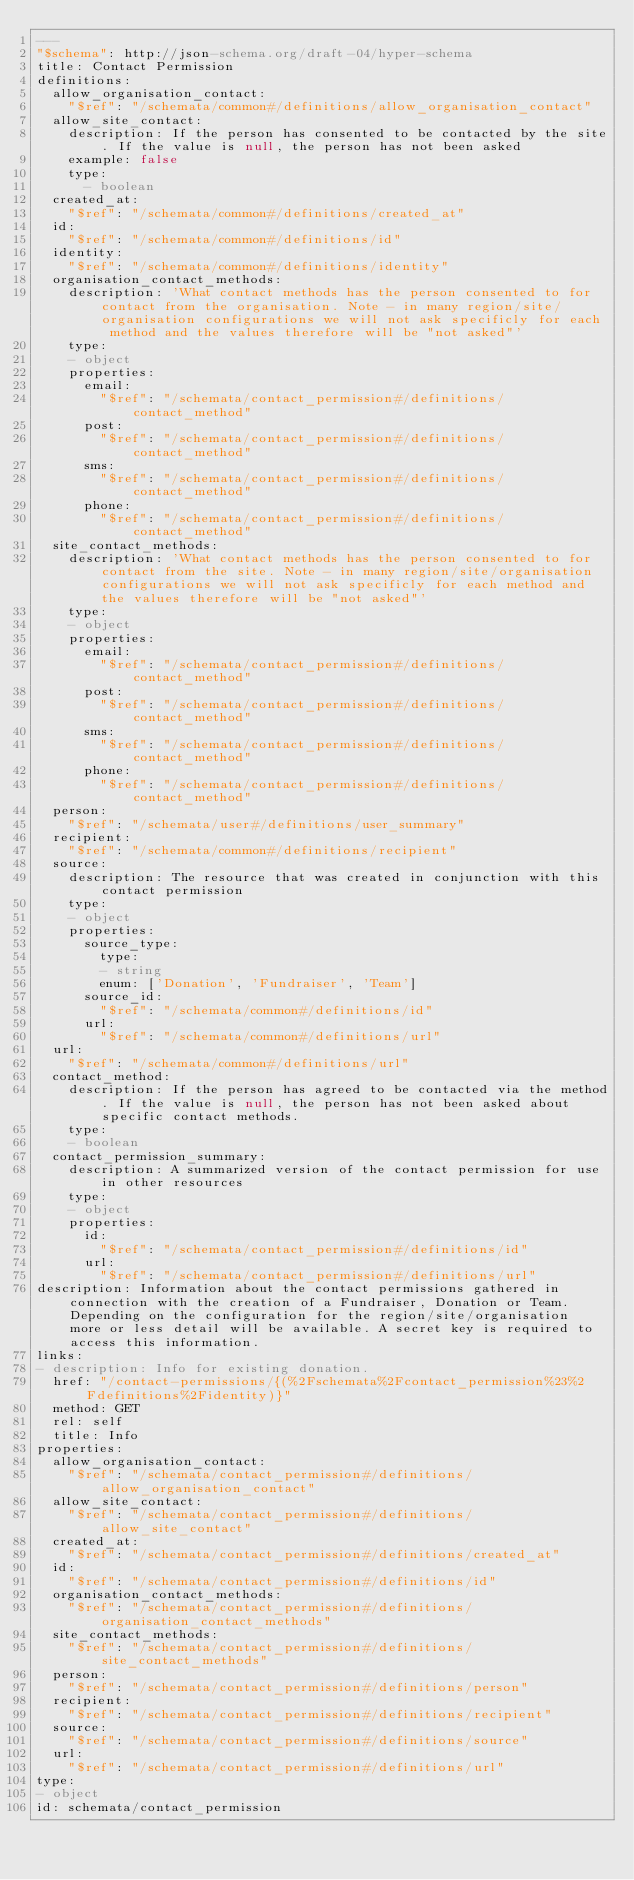Convert code to text. <code><loc_0><loc_0><loc_500><loc_500><_YAML_>---
"$schema": http://json-schema.org/draft-04/hyper-schema
title: Contact Permission
definitions:
  allow_organisation_contact:
    "$ref": "/schemata/common#/definitions/allow_organisation_contact"
  allow_site_contact:
    description: If the person has consented to be contacted by the site. If the value is null, the person has not been asked
    example: false
    type:
      - boolean
  created_at:
    "$ref": "/schemata/common#/definitions/created_at"
  id:
    "$ref": "/schemata/common#/definitions/id"
  identity:
    "$ref": "/schemata/common#/definitions/identity"
  organisation_contact_methods:
    description: 'What contact methods has the person consented to for contact from the organisation. Note - in many region/site/organisation configurations we will not ask specificly for each method and the values therefore will be "not asked"'
    type:
    - object
    properties:
      email:
        "$ref": "/schemata/contact_permission#/definitions/contact_method"
      post:
        "$ref": "/schemata/contact_permission#/definitions/contact_method"
      sms:
        "$ref": "/schemata/contact_permission#/definitions/contact_method"
      phone:
        "$ref": "/schemata/contact_permission#/definitions/contact_method"
  site_contact_methods:
    description: 'What contact methods has the person consented to for contact from the site. Note - in many region/site/organisation configurations we will not ask specificly for each method and the values therefore will be "not asked"'
    type:
    - object
    properties:
      email:
        "$ref": "/schemata/contact_permission#/definitions/contact_method"
      post:
        "$ref": "/schemata/contact_permission#/definitions/contact_method"
      sms:
        "$ref": "/schemata/contact_permission#/definitions/contact_method"
      phone:
        "$ref": "/schemata/contact_permission#/definitions/contact_method"
  person:
    "$ref": "/schemata/user#/definitions/user_summary"
  recipient:
    "$ref": "/schemata/common#/definitions/recipient"
  source:
    description: The resource that was created in conjunction with this contact permission
    type:
    - object
    properties:
      source_type:
        type:
        - string
        enum: ['Donation', 'Fundraiser', 'Team']
      source_id:
        "$ref": "/schemata/common#/definitions/id"
      url:
        "$ref": "/schemata/common#/definitions/url"
  url:
    "$ref": "/schemata/common#/definitions/url"
  contact_method:
    description: If the person has agreed to be contacted via the method. If the value is null, the person has not been asked about specific contact methods.
    type:
    - boolean
  contact_permission_summary:
    description: A summarized version of the contact permission for use in other resources
    type:
    - object
    properties:
      id:
        "$ref": "/schemata/contact_permission#/definitions/id"
      url:
        "$ref": "/schemata/contact_permission#/definitions/url"
description: Information about the contact permissions gathered in connection with the creation of a Fundraiser, Donation or Team. Depending on the configuration for the region/site/organisation more or less detail will be available. A secret key is required to access this information.
links:
- description: Info for existing donation.
  href: "/contact-permissions/{(%2Fschemata%2Fcontact_permission%23%2Fdefinitions%2Fidentity)}"
  method: GET
  rel: self
  title: Info
properties:
  allow_organisation_contact:
    "$ref": "/schemata/contact_permission#/definitions/allow_organisation_contact"
  allow_site_contact:
    "$ref": "/schemata/contact_permission#/definitions/allow_site_contact"
  created_at:
    "$ref": "/schemata/contact_permission#/definitions/created_at"
  id:
    "$ref": "/schemata/contact_permission#/definitions/id"
  organisation_contact_methods:
    "$ref": "/schemata/contact_permission#/definitions/organisation_contact_methods"
  site_contact_methods:
    "$ref": "/schemata/contact_permission#/definitions/site_contact_methods"
  person:
    "$ref": "/schemata/contact_permission#/definitions/person"
  recipient:
    "$ref": "/schemata/contact_permission#/definitions/recipient"
  source:
    "$ref": "/schemata/contact_permission#/definitions/source"
  url:
    "$ref": "/schemata/contact_permission#/definitions/url"
type:
- object
id: schemata/contact_permission
</code> 